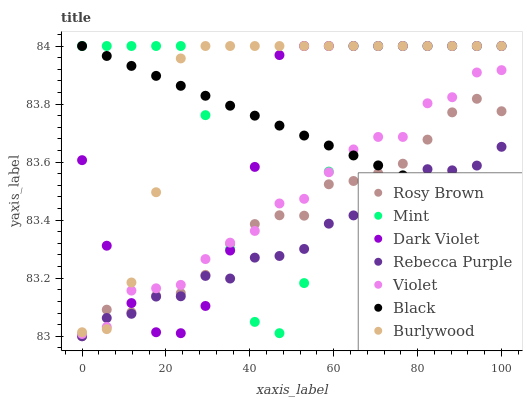Does Rebecca Purple have the minimum area under the curve?
Answer yes or no. Yes. Does Burlywood have the maximum area under the curve?
Answer yes or no. Yes. Does Rosy Brown have the minimum area under the curve?
Answer yes or no. No. Does Rosy Brown have the maximum area under the curve?
Answer yes or no. No. Is Black the smoothest?
Answer yes or no. Yes. Is Mint the roughest?
Answer yes or no. Yes. Is Rosy Brown the smoothest?
Answer yes or no. No. Is Rosy Brown the roughest?
Answer yes or no. No. Does Rosy Brown have the lowest value?
Answer yes or no. Yes. Does Dark Violet have the lowest value?
Answer yes or no. No. Does Mint have the highest value?
Answer yes or no. Yes. Does Rosy Brown have the highest value?
Answer yes or no. No. Does Mint intersect Rosy Brown?
Answer yes or no. Yes. Is Mint less than Rosy Brown?
Answer yes or no. No. Is Mint greater than Rosy Brown?
Answer yes or no. No. 